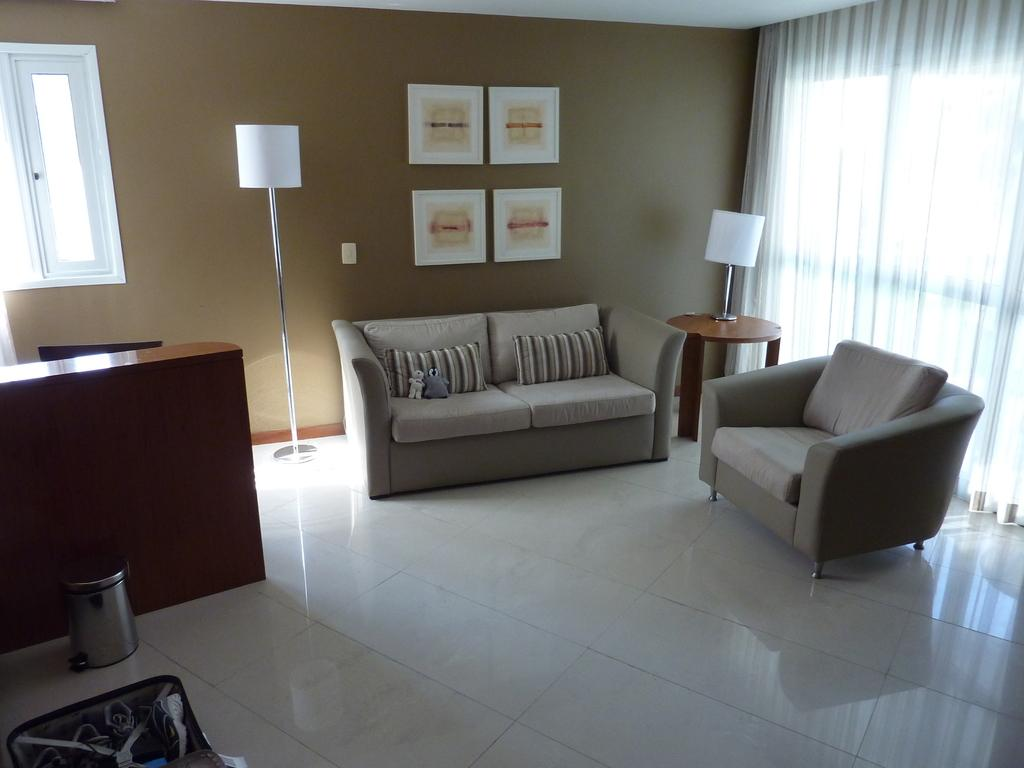What type of structure can be seen in the image? There is a wall in the image. What is located on the wall? There is a window in the image. What decorative items are present in the image? There are photo frames in the image. What type of lighting is visible in the image? There is a lamp in the image. What type of window treatment is present in the image? There are curtains in the image. What type of seating is visible in the image? There are sofas in the image. Where is the dustbin located in the image? The dustbin is on the left side of the image. What type of brick is used to construct the apparatus in the image? There is no apparatus present in the image, and therefore no bricks are used in its construction. What type of journey is depicted in the image? There is no journey depicted in the image; it features a wall, window, photo frames, lamp, curtains, sofas, and a dustbin. 